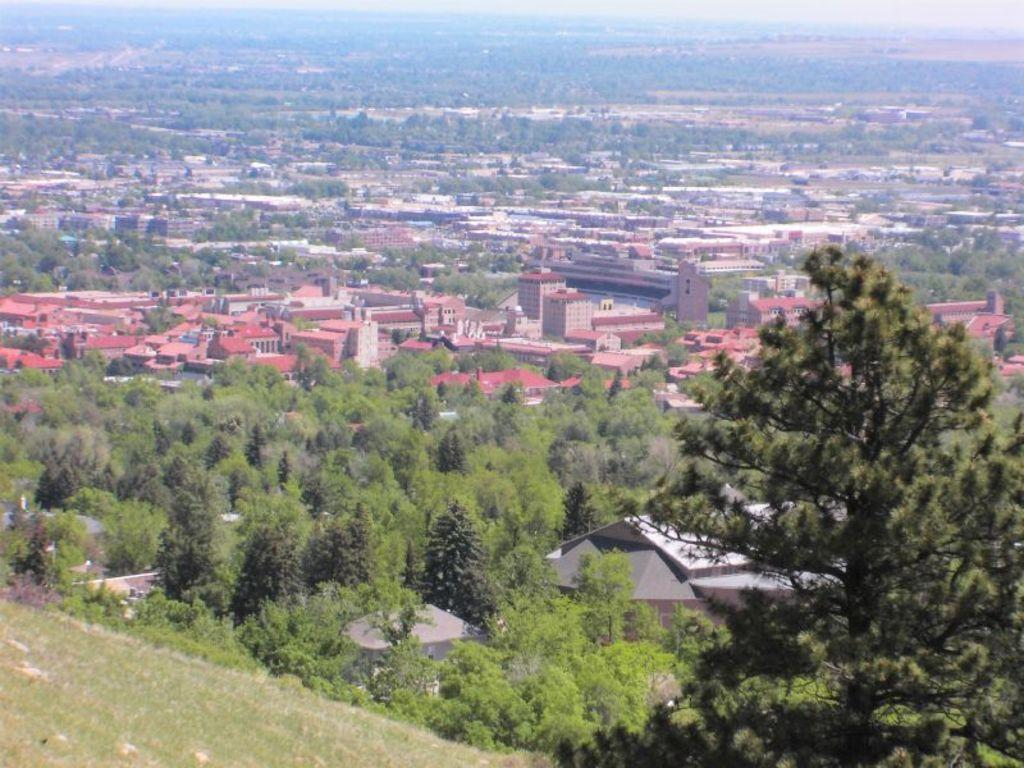What type of structures can be seen in the image? There are buildings in the image. What type of vegetation is present in the image? There are trees in the image. What type of ground cover is visible in the image? There is grass in the image. Where is the advertisement for the competition located in the image? There is no advertisement or competition present in the image. What type of bird's nest can be seen in the trees in the image? There is no bird's nest visible in the image; only trees are present. 